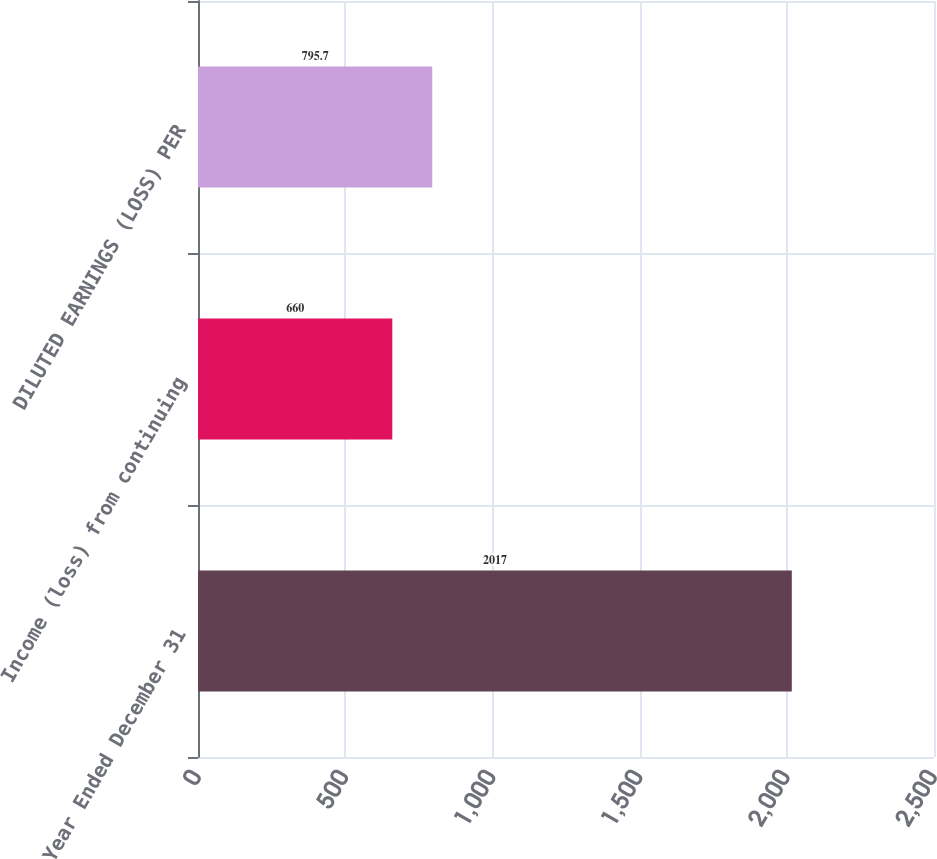Convert chart to OTSL. <chart><loc_0><loc_0><loc_500><loc_500><bar_chart><fcel>Year Ended December 31<fcel>Income (loss) from continuing<fcel>DILUTED EARNINGS (LOSS) PER<nl><fcel>2017<fcel>660<fcel>795.7<nl></chart> 